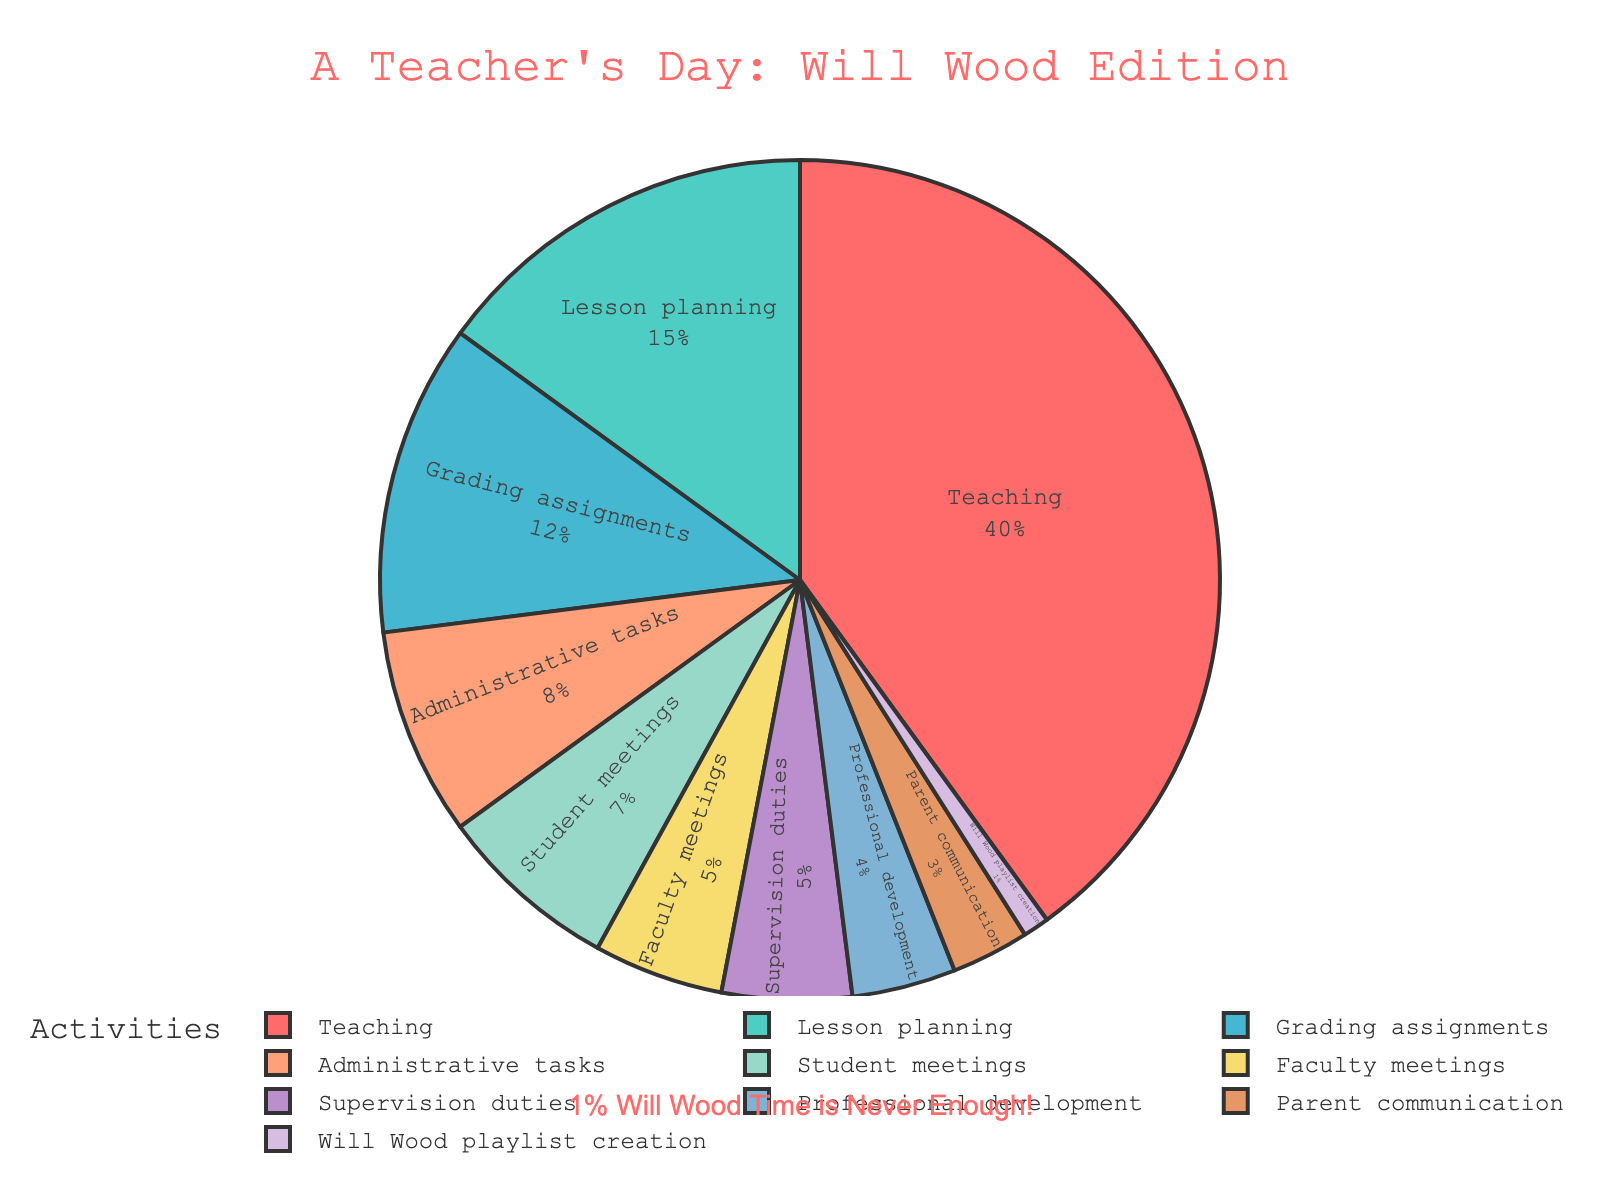Which activity takes up the largest portion of a teacher's day? To find the activity taking up the largest portion, simply look for the activity with the largest slice of the pie chart. Here, 'Teaching' has the largest portion.
Answer: Teaching What percentage of the teacher's day is dedicated to meetings (Student meetings + Faculty meetings)? Add the percentages of 'Student meetings' (7%) and 'Faculty meetings' (5%). The sum is 7 + 5 = 12%.
Answer: 12% Which activity is allocated the least amount of time? Look for the smallest slice in the pie chart. 'Will Wood playlist creation' takes up the smallest portion at 1%.
Answer: Will Wood playlist creation Is the time spent on Grading assignments more than the time spent on Faculty meetings? Compare the slices for 'Grading assignments' (12%) and 'Faculty meetings' (5%). Since 12% is greater than 5%, the answer is yes.
Answer: Yes What is the total percentage of time spent on Administrative tasks, Supervision duties, and Professional development? Add the percentages: Administrative tasks (8%) + Supervision duties (5%) + Professional development (4%). The total is 8 + 5 + 4 = 17%.
Answer: 17% How does the time spent on Lesson planning compare to the time spent on Teaching? Compare the percentages for 'Lesson planning' (15%) and 'Teaching' (40%). Since 15% is less than 40%, Lesson planning takes less time.
Answer: Less What color represents the time spent on Parent communication? The slice for 'Parent communication' is represented by the peach color.
Answer: Peach If the time for Faculty meetings was doubled, what percentage of the day would it then take? Doubling the percentage for 'Faculty meetings' (5%) gives us 5 * 2 = 10%.
Answer: 10% Which activities together make up more than half of the teacher's day? Identify the activities with percentages adding up to more than 50%. 'Teaching' (40%) + 'Lesson planning' (15%) = 55%, which is more than half.
Answer: Teaching and Lesson planning Compare the combined time for Grading assignments and Administrative tasks to Teaching. Which is greater? Add percentages for 'Grading assignments' (12%) and 'Administrative tasks' (8%), giving us 12 + 8 = 20%. Since 'Teaching' is 40%, 40% is greater than 20%.
Answer: Teaching is greater 